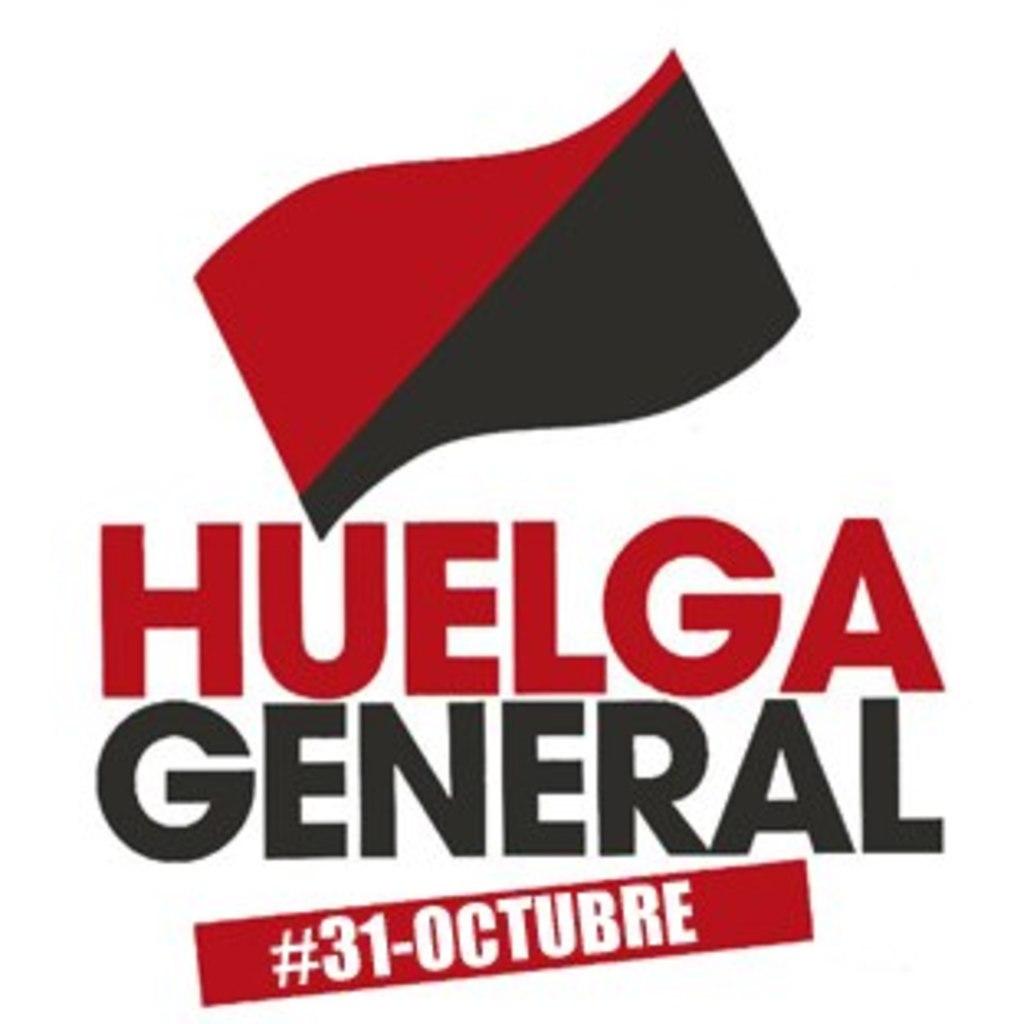When is the event?
Provide a short and direct response. 31 octubre. What is this poster for?
Make the answer very short. Huelga general. 